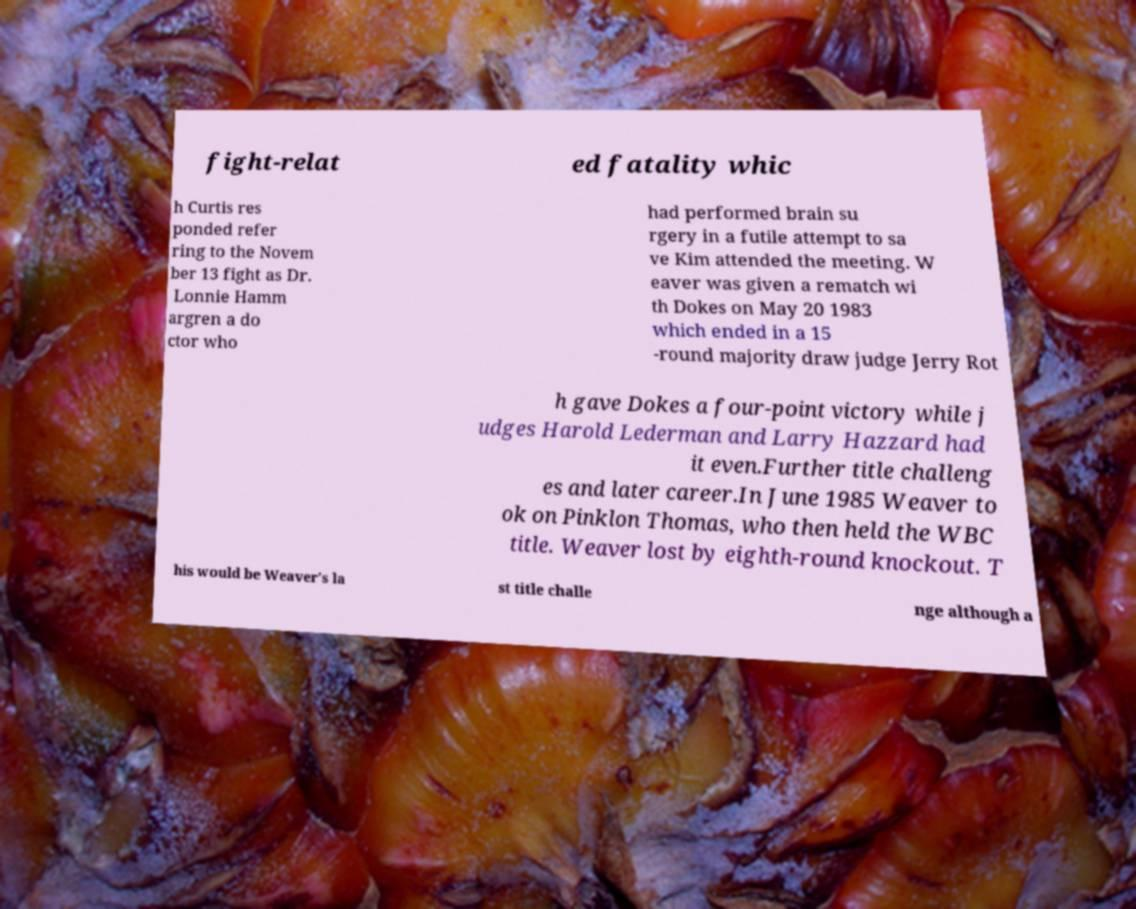What messages or text are displayed in this image? I need them in a readable, typed format. fight-relat ed fatality whic h Curtis res ponded refer ring to the Novem ber 13 fight as Dr. Lonnie Hamm argren a do ctor who had performed brain su rgery in a futile attempt to sa ve Kim attended the meeting. W eaver was given a rematch wi th Dokes on May 20 1983 which ended in a 15 -round majority draw judge Jerry Rot h gave Dokes a four-point victory while j udges Harold Lederman and Larry Hazzard had it even.Further title challeng es and later career.In June 1985 Weaver to ok on Pinklon Thomas, who then held the WBC title. Weaver lost by eighth-round knockout. T his would be Weaver's la st title challe nge although a 